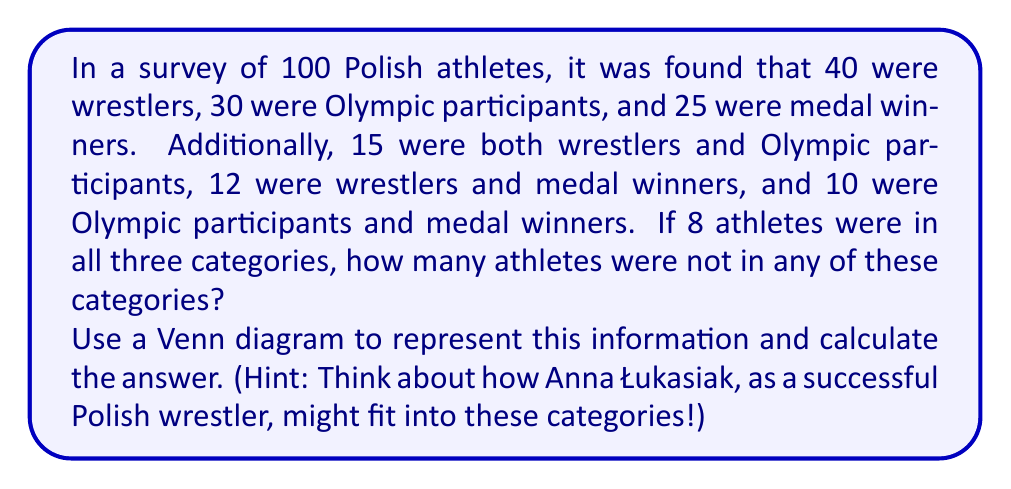Could you help me with this problem? Let's approach this step-by-step using a Venn diagram:

1) Let's define our sets:
   W: Wrestlers
   O: Olympic participants
   M: Medal winners

2) We can represent this information in a Venn diagram:

[asy]
unitsize(1cm);

pair A = (0,0), B = (2,0), C = (1,1.7);
real r = 1.2;

draw(circle(A,r));
draw(circle(B,r));
draw(circle(C,r));

label("W", A + (-1.2,-1.2));
label("O", B + (1.2,-1.2));
label("M", C + (0,1.2));

label("8", (1,0.6));

label("7", (0.5,0));
label("2", (1.5,0));

label("4", (0.3,0.9));
label("2", (1.7,0.9));

label("19", (-0.6,-0.3));
label("5", (2.6,-0.3));
label("9", (1,1.5));

[/asy]

3) Let's fill in what we know:
   - Total athletes: 100
   - Wrestlers (W): 40
   - Olympic participants (O): 30
   - Medal winners (M): 25
   - W ∩ O: 15
   - W ∩ M: 12
   - O ∩ M: 10
   - W ∩ O ∩ M: 8

4) We can now calculate the unique regions in our Venn diagram:
   - W only: 40 - 15 - 12 + 8 = 21
   - O only: 30 - 15 - 10 + 8 = 13
   - M only: 25 - 12 - 10 + 8 = 11
   - W ∩ O (not M): 15 - 8 = 7
   - W ∩ M (not O): 12 - 8 = 4
   - O ∩ M (not W): 10 - 8 = 2

5) Now, let's sum all the regions in our Venn diagram:
   21 + 13 + 11 + 7 + 4 + 2 + 8 = 66

6) To find how many athletes are not in any category, we subtract this sum from the total:
   100 - 66 = 34

Therefore, 34 athletes are not in any of these categories.
Answer: 34 athletes 